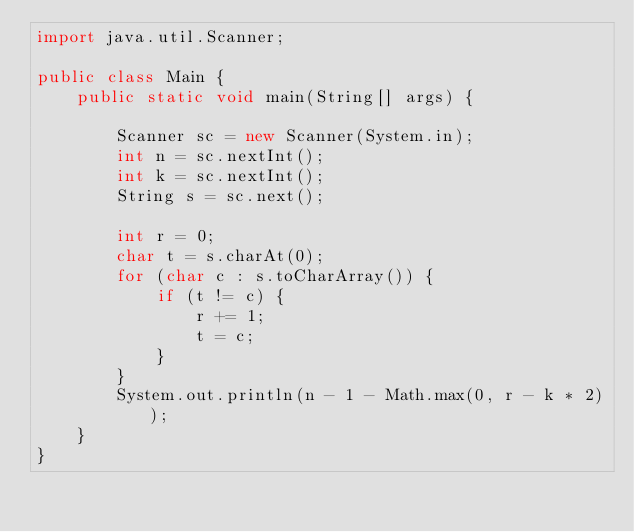Convert code to text. <code><loc_0><loc_0><loc_500><loc_500><_Java_>import java.util.Scanner;

public class Main {
	public static void main(String[] args) {

		Scanner sc = new Scanner(System.in);
		int n = sc.nextInt();
		int k = sc.nextInt();
		String s = sc.next();

		int r = 0;
		char t = s.charAt(0);
		for (char c : s.toCharArray()) {
			if (t != c) {
				r += 1;
				t = c;
			}
		}
		System.out.println(n - 1 - Math.max(0, r - k * 2));
	}
}</code> 